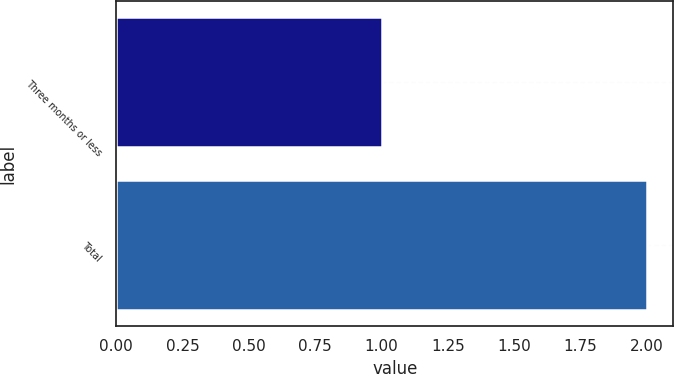<chart> <loc_0><loc_0><loc_500><loc_500><bar_chart><fcel>Three months or less<fcel>Total<nl><fcel>1<fcel>2<nl></chart> 